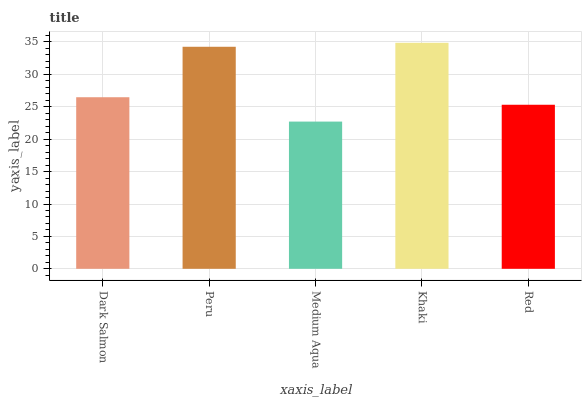Is Medium Aqua the minimum?
Answer yes or no. Yes. Is Khaki the maximum?
Answer yes or no. Yes. Is Peru the minimum?
Answer yes or no. No. Is Peru the maximum?
Answer yes or no. No. Is Peru greater than Dark Salmon?
Answer yes or no. Yes. Is Dark Salmon less than Peru?
Answer yes or no. Yes. Is Dark Salmon greater than Peru?
Answer yes or no. No. Is Peru less than Dark Salmon?
Answer yes or no. No. Is Dark Salmon the high median?
Answer yes or no. Yes. Is Dark Salmon the low median?
Answer yes or no. Yes. Is Medium Aqua the high median?
Answer yes or no. No. Is Red the low median?
Answer yes or no. No. 